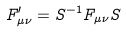Convert formula to latex. <formula><loc_0><loc_0><loc_500><loc_500>F ^ { \prime } _ { \mu \nu } = S ^ { - 1 } F _ { \mu \nu } S</formula> 